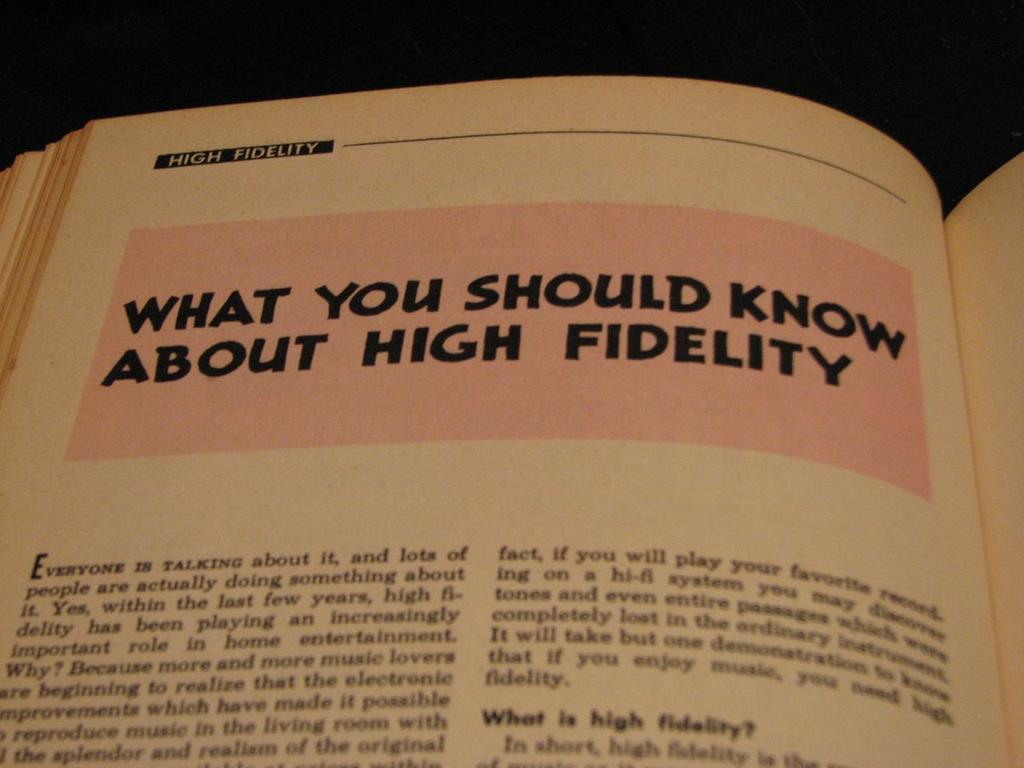What is the chapter teaching you about?
Ensure brevity in your answer.  High fidelity. What is the title of the chapter?
Your response must be concise. What you should know about high fidelity. 